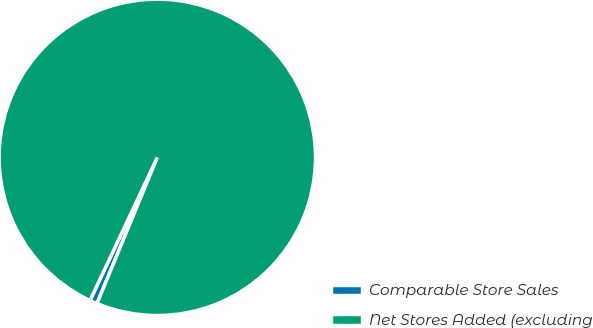Convert chart. <chart><loc_0><loc_0><loc_500><loc_500><pie_chart><fcel>Comparable Store Sales<fcel>Net Stores Added (excluding<nl><fcel>0.77%<fcel>99.23%<nl></chart> 